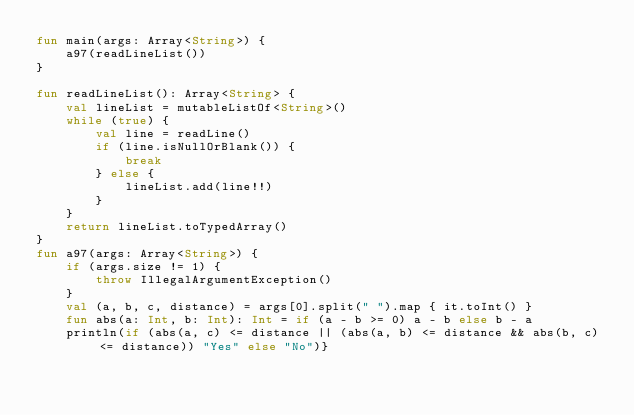Convert code to text. <code><loc_0><loc_0><loc_500><loc_500><_Kotlin_>fun main(args: Array<String>) {
    a97(readLineList())
}

fun readLineList(): Array<String> {
    val lineList = mutableListOf<String>()
    while (true) {
        val line = readLine()
        if (line.isNullOrBlank()) {
            break
        } else {
            lineList.add(line!!)
        }
    }
    return lineList.toTypedArray()
}
fun a97(args: Array<String>) {
    if (args.size != 1) {
        throw IllegalArgumentException()
    }
    val (a, b, c, distance) = args[0].split(" ").map { it.toInt() }
    fun abs(a: Int, b: Int): Int = if (a - b >= 0) a - b else b - a
    println(if (abs(a, c) <= distance || (abs(a, b) <= distance && abs(b, c) <= distance)) "Yes" else "No")}</code> 